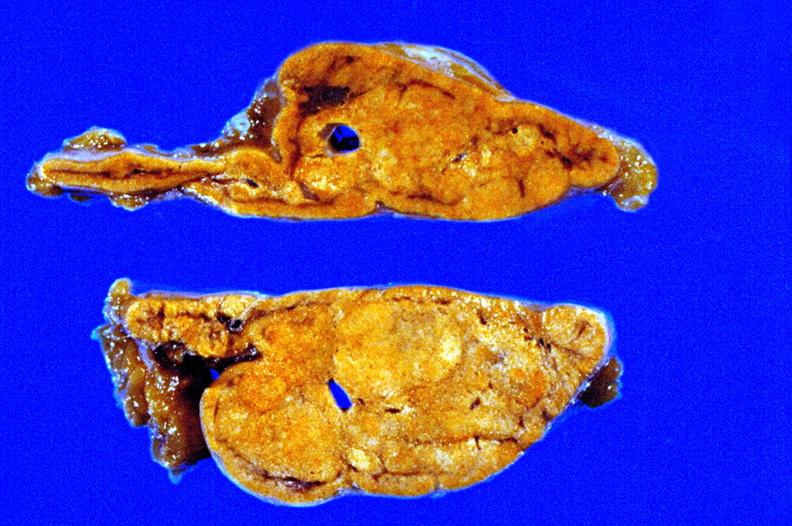s adrenal present?
Answer the question using a single word or phrase. Yes 